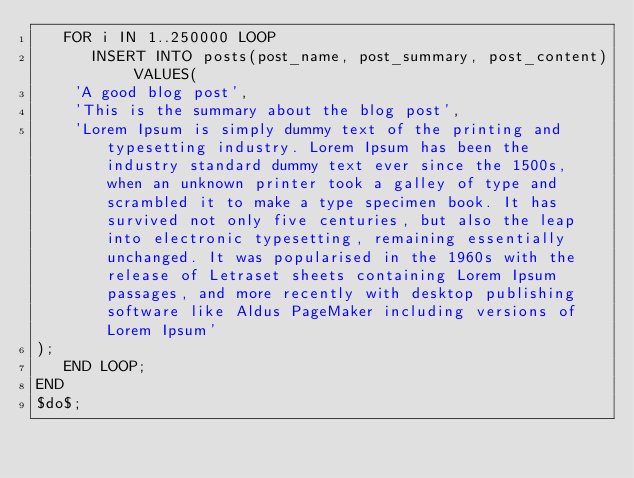Convert code to text. <code><loc_0><loc_0><loc_500><loc_500><_SQL_>   FOR i IN 1..250000 LOOP
      INSERT INTO posts(post_name, post_summary, post_content) VALUES(
    'A good blog post', 
    'This is the summary about the blog post', 
    'Lorem Ipsum is simply dummy text of the printing and typesetting industry. Lorem Ipsum has been the industry standard dummy text ever since the 1500s, when an unknown printer took a galley of type and scrambled it to make a type specimen book. It has survived not only five centuries, but also the leap into electronic typesetting, remaining essentially unchanged. It was popularised in the 1960s with the release of Letraset sheets containing Lorem Ipsum passages, and more recently with desktop publishing software like Aldus PageMaker including versions of Lorem Ipsum'
);
   END LOOP;
END
$do$;</code> 